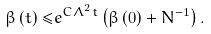Convert formula to latex. <formula><loc_0><loc_0><loc_500><loc_500>\beta \left ( t \right ) \leq & e ^ { C \Lambda ^ { 2 } t } \left ( \beta \left ( 0 \right ) + N ^ { - 1 } \right ) .</formula> 